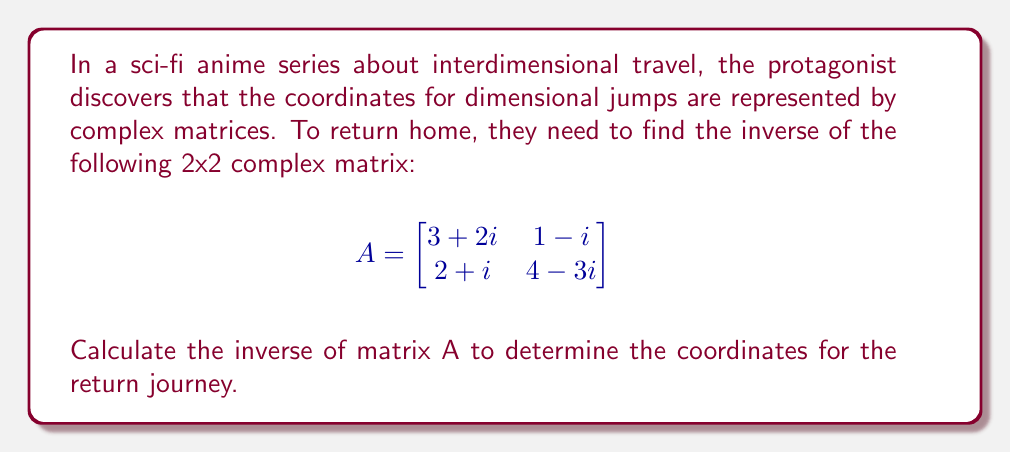Show me your answer to this math problem. To find the inverse of a 2x2 complex matrix, we'll follow these steps:

1) First, we calculate the determinant of A:
   $$\det(A) = (3+2i)(4-3i) - (1-i)(2+i)$$
   $$= (12-9i+8i-6i^2) - (2+i-i-i^2)$$
   $$= (12-i+6) - (2+1)$$
   $$= 18-i-3 = 15-i$$

2) Now, we calculate the adjugate matrix:
   $$adj(A) = \begin{bmatrix}
   4-3i & -(1-i) \\
   -(2+i) & 3+2i
   \end{bmatrix}$$

3) The inverse is given by:
   $$A^{-1} = \frac{1}{\det(A)} \cdot adj(A)$$

4) Substituting our values:
   $$A^{-1} = \frac{1}{15-i} \cdot \begin{bmatrix}
   4-3i & -(1-i) \\
   -(2+i) & 3+2i
   \end{bmatrix}$$

5) To simplify the fraction, we multiply numerator and denominator by the complex conjugate of the denominator:
   $$\frac{1}{15-i} \cdot \frac{15+i}{15+i} = \frac{15+i}{(15)^2+1^2} = \frac{15+i}{226}$$

6) Now we multiply this by each element of the adjugate matrix:

   $$A^{-1} = \frac{1}{226} \begin{bmatrix}
   (4-3i)(15+i) & -(1-i)(15+i) \\
   -(2+i)(15+i) & (3+2i)(15+i)
   \end{bmatrix}$$

7) Simplifying each element:
   $$(4-3i)(15+i) = 60+4i-45i-3i^2 = 63-41i$$
   $$-(1-i)(15+i) = -15-i+15i+i^2 = -16+14i$$
   $$-(2+i)(15+i) = -30-2i-15i-i^2 = -31-17i$$
   $$(3+2i)(15+i) = 45+3i+30i+2i^2 = 43+33i$$

8) Therefore, the final inverse matrix is:

   $$A^{-1} = \frac{1}{226} \begin{bmatrix}
   63-41i & -16+14i \\
   -31-17i & 43+33i
   \end{bmatrix}$$
Answer: $$A^{-1} = \frac{1}{226} \begin{bmatrix}
63-41i & -16+14i \\
-31-17i & 43+33i
\end{bmatrix}$$ 